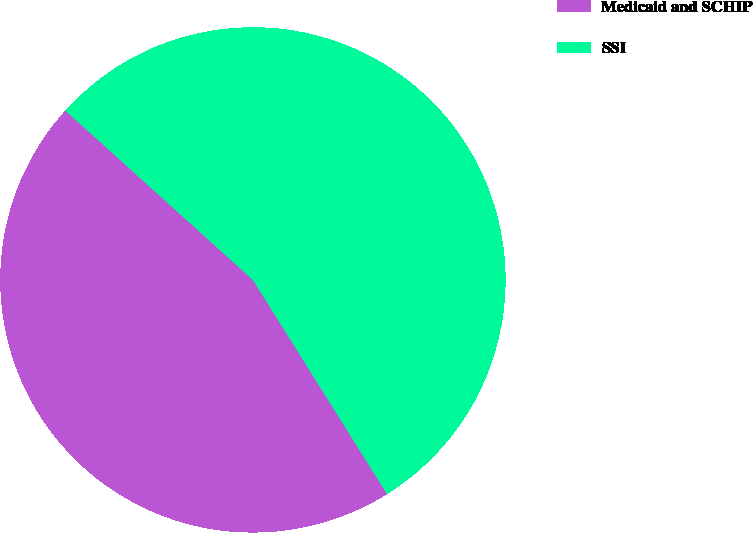Convert chart. <chart><loc_0><loc_0><loc_500><loc_500><pie_chart><fcel>Medicaid and SCHIP<fcel>SSI<nl><fcel>45.59%<fcel>54.41%<nl></chart> 